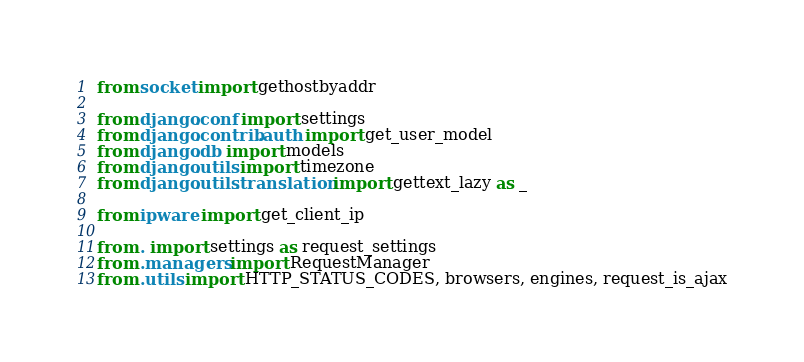<code> <loc_0><loc_0><loc_500><loc_500><_Python_>from socket import gethostbyaddr

from django.conf import settings
from django.contrib.auth import get_user_model
from django.db import models
from django.utils import timezone
from django.utils.translation import gettext_lazy as _

from ipware import get_client_ip

from . import settings as request_settings
from .managers import RequestManager
from .utils import HTTP_STATUS_CODES, browsers, engines, request_is_ajax
</code> 